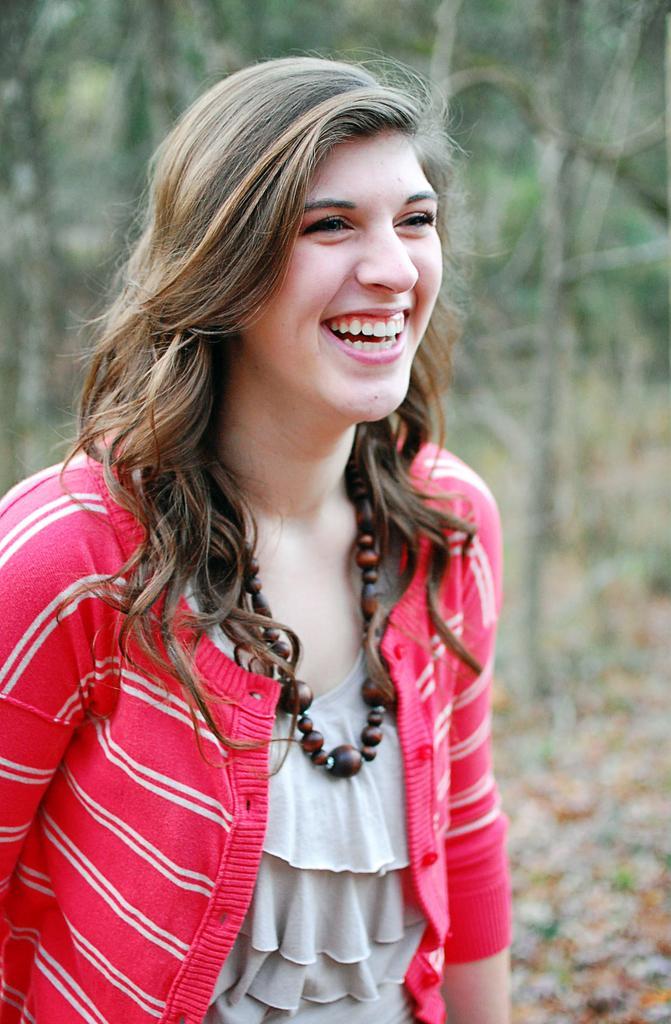Please provide a concise description of this image. In the middle of the image a woman is standing and smiling. Behind her there are some trees. 